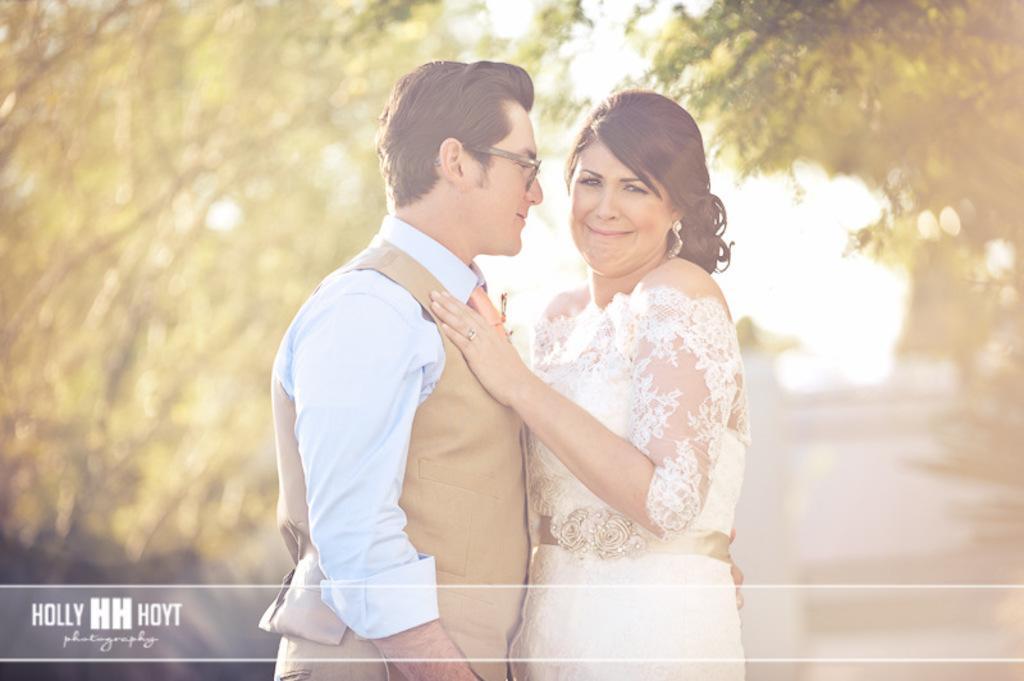Please provide a concise description of this image. In this picture, we see a man and a woman are standing. The man is wearing the spectacles and he is smiling. Both of them are posing for the photo. On either side of the picture, we see the trees. In the background, we see the sky. This picture is blurred in the background. 